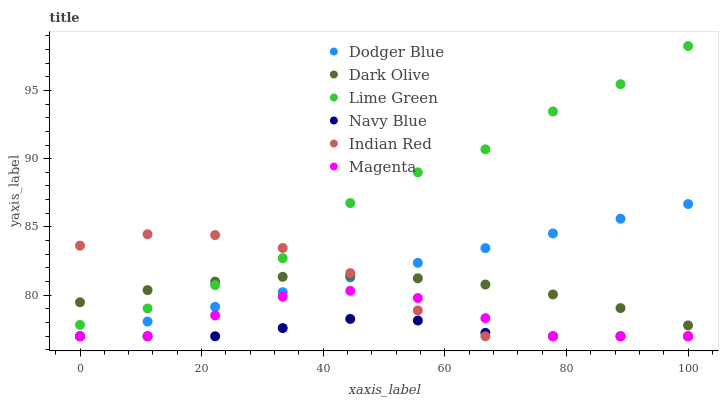Does Navy Blue have the minimum area under the curve?
Answer yes or no. Yes. Does Lime Green have the maximum area under the curve?
Answer yes or no. Yes. Does Dark Olive have the minimum area under the curve?
Answer yes or no. No. Does Dark Olive have the maximum area under the curve?
Answer yes or no. No. Is Dodger Blue the smoothest?
Answer yes or no. Yes. Is Lime Green the roughest?
Answer yes or no. Yes. Is Dark Olive the smoothest?
Answer yes or no. No. Is Dark Olive the roughest?
Answer yes or no. No. Does Navy Blue have the lowest value?
Answer yes or no. Yes. Does Dark Olive have the lowest value?
Answer yes or no. No. Does Lime Green have the highest value?
Answer yes or no. Yes. Does Dark Olive have the highest value?
Answer yes or no. No. Is Navy Blue less than Lime Green?
Answer yes or no. Yes. Is Dark Olive greater than Magenta?
Answer yes or no. Yes. Does Navy Blue intersect Dodger Blue?
Answer yes or no. Yes. Is Navy Blue less than Dodger Blue?
Answer yes or no. No. Is Navy Blue greater than Dodger Blue?
Answer yes or no. No. Does Navy Blue intersect Lime Green?
Answer yes or no. No. 